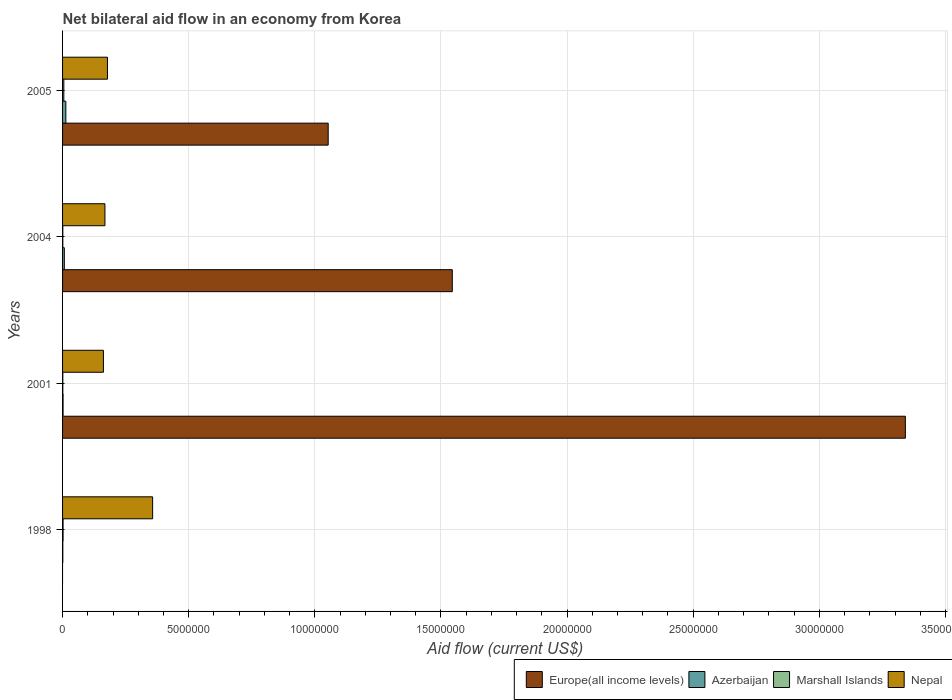How many different coloured bars are there?
Offer a very short reply. 4. Are the number of bars per tick equal to the number of legend labels?
Offer a very short reply. No. How many bars are there on the 4th tick from the top?
Provide a short and direct response. 3. How many bars are there on the 3rd tick from the bottom?
Ensure brevity in your answer.  4. Across all years, what is the minimum net bilateral aid flow in Europe(all income levels)?
Your answer should be compact. 0. In which year was the net bilateral aid flow in Marshall Islands maximum?
Your answer should be very brief. 2005. What is the total net bilateral aid flow in Marshall Islands in the graph?
Make the answer very short. 9.00e+04. What is the difference between the net bilateral aid flow in Nepal in 2004 and that in 2005?
Your response must be concise. -1.00e+05. What is the difference between the net bilateral aid flow in Europe(all income levels) in 1998 and the net bilateral aid flow in Marshall Islands in 2001?
Ensure brevity in your answer.  -10000. What is the average net bilateral aid flow in Nepal per year?
Keep it short and to the point. 2.16e+06. In the year 2001, what is the difference between the net bilateral aid flow in Nepal and net bilateral aid flow in Azerbaijan?
Offer a terse response. 1.60e+06. What is the ratio of the net bilateral aid flow in Marshall Islands in 2004 to that in 2005?
Your answer should be very brief. 0.2. Is the difference between the net bilateral aid flow in Nepal in 1998 and 2004 greater than the difference between the net bilateral aid flow in Azerbaijan in 1998 and 2004?
Provide a short and direct response. Yes. What is the difference between the highest and the second highest net bilateral aid flow in Marshall Islands?
Your answer should be compact. 3.00e+04. In how many years, is the net bilateral aid flow in Azerbaijan greater than the average net bilateral aid flow in Azerbaijan taken over all years?
Your response must be concise. 2. Is the sum of the net bilateral aid flow in Marshall Islands in 1998 and 2005 greater than the maximum net bilateral aid flow in Azerbaijan across all years?
Offer a very short reply. No. Is it the case that in every year, the sum of the net bilateral aid flow in Marshall Islands and net bilateral aid flow in Nepal is greater than the sum of net bilateral aid flow in Europe(all income levels) and net bilateral aid flow in Azerbaijan?
Give a very brief answer. Yes. Does the graph contain any zero values?
Your answer should be very brief. Yes. Does the graph contain grids?
Your answer should be compact. Yes. Where does the legend appear in the graph?
Offer a very short reply. Bottom right. How many legend labels are there?
Give a very brief answer. 4. How are the legend labels stacked?
Provide a succinct answer. Horizontal. What is the title of the graph?
Your answer should be compact. Net bilateral aid flow in an economy from Korea. What is the label or title of the X-axis?
Make the answer very short. Aid flow (current US$). What is the Aid flow (current US$) of Azerbaijan in 1998?
Offer a terse response. 10000. What is the Aid flow (current US$) in Nepal in 1998?
Keep it short and to the point. 3.57e+06. What is the Aid flow (current US$) in Europe(all income levels) in 2001?
Make the answer very short. 3.34e+07. What is the Aid flow (current US$) of Azerbaijan in 2001?
Your answer should be compact. 2.00e+04. What is the Aid flow (current US$) in Nepal in 2001?
Offer a very short reply. 1.62e+06. What is the Aid flow (current US$) of Europe(all income levels) in 2004?
Keep it short and to the point. 1.54e+07. What is the Aid flow (current US$) in Azerbaijan in 2004?
Provide a succinct answer. 7.00e+04. What is the Aid flow (current US$) of Nepal in 2004?
Offer a terse response. 1.68e+06. What is the Aid flow (current US$) of Europe(all income levels) in 2005?
Your response must be concise. 1.05e+07. What is the Aid flow (current US$) in Nepal in 2005?
Keep it short and to the point. 1.78e+06. Across all years, what is the maximum Aid flow (current US$) of Europe(all income levels)?
Your response must be concise. 3.34e+07. Across all years, what is the maximum Aid flow (current US$) in Azerbaijan?
Provide a short and direct response. 1.30e+05. Across all years, what is the maximum Aid flow (current US$) of Marshall Islands?
Offer a terse response. 5.00e+04. Across all years, what is the maximum Aid flow (current US$) of Nepal?
Offer a very short reply. 3.57e+06. Across all years, what is the minimum Aid flow (current US$) in Europe(all income levels)?
Your response must be concise. 0. Across all years, what is the minimum Aid flow (current US$) of Nepal?
Make the answer very short. 1.62e+06. What is the total Aid flow (current US$) in Europe(all income levels) in the graph?
Provide a short and direct response. 5.94e+07. What is the total Aid flow (current US$) in Azerbaijan in the graph?
Offer a very short reply. 2.30e+05. What is the total Aid flow (current US$) of Nepal in the graph?
Provide a short and direct response. 8.65e+06. What is the difference between the Aid flow (current US$) in Azerbaijan in 1998 and that in 2001?
Your answer should be compact. -10000. What is the difference between the Aid flow (current US$) in Nepal in 1998 and that in 2001?
Provide a succinct answer. 1.95e+06. What is the difference between the Aid flow (current US$) of Azerbaijan in 1998 and that in 2004?
Ensure brevity in your answer.  -6.00e+04. What is the difference between the Aid flow (current US$) of Marshall Islands in 1998 and that in 2004?
Your response must be concise. 10000. What is the difference between the Aid flow (current US$) of Nepal in 1998 and that in 2004?
Give a very brief answer. 1.89e+06. What is the difference between the Aid flow (current US$) in Nepal in 1998 and that in 2005?
Your response must be concise. 1.79e+06. What is the difference between the Aid flow (current US$) of Europe(all income levels) in 2001 and that in 2004?
Provide a succinct answer. 1.80e+07. What is the difference between the Aid flow (current US$) of Nepal in 2001 and that in 2004?
Offer a very short reply. -6.00e+04. What is the difference between the Aid flow (current US$) of Europe(all income levels) in 2001 and that in 2005?
Your answer should be very brief. 2.29e+07. What is the difference between the Aid flow (current US$) in Azerbaijan in 2001 and that in 2005?
Ensure brevity in your answer.  -1.10e+05. What is the difference between the Aid flow (current US$) in Nepal in 2001 and that in 2005?
Your answer should be compact. -1.60e+05. What is the difference between the Aid flow (current US$) of Europe(all income levels) in 2004 and that in 2005?
Your response must be concise. 4.92e+06. What is the difference between the Aid flow (current US$) in Azerbaijan in 2004 and that in 2005?
Provide a succinct answer. -6.00e+04. What is the difference between the Aid flow (current US$) of Nepal in 2004 and that in 2005?
Provide a succinct answer. -1.00e+05. What is the difference between the Aid flow (current US$) of Azerbaijan in 1998 and the Aid flow (current US$) of Marshall Islands in 2001?
Give a very brief answer. 0. What is the difference between the Aid flow (current US$) of Azerbaijan in 1998 and the Aid flow (current US$) of Nepal in 2001?
Your answer should be compact. -1.61e+06. What is the difference between the Aid flow (current US$) of Marshall Islands in 1998 and the Aid flow (current US$) of Nepal in 2001?
Your response must be concise. -1.60e+06. What is the difference between the Aid flow (current US$) of Azerbaijan in 1998 and the Aid flow (current US$) of Marshall Islands in 2004?
Ensure brevity in your answer.  0. What is the difference between the Aid flow (current US$) of Azerbaijan in 1998 and the Aid flow (current US$) of Nepal in 2004?
Your answer should be compact. -1.67e+06. What is the difference between the Aid flow (current US$) of Marshall Islands in 1998 and the Aid flow (current US$) of Nepal in 2004?
Your response must be concise. -1.66e+06. What is the difference between the Aid flow (current US$) of Azerbaijan in 1998 and the Aid flow (current US$) of Nepal in 2005?
Give a very brief answer. -1.77e+06. What is the difference between the Aid flow (current US$) of Marshall Islands in 1998 and the Aid flow (current US$) of Nepal in 2005?
Your response must be concise. -1.76e+06. What is the difference between the Aid flow (current US$) of Europe(all income levels) in 2001 and the Aid flow (current US$) of Azerbaijan in 2004?
Ensure brevity in your answer.  3.33e+07. What is the difference between the Aid flow (current US$) in Europe(all income levels) in 2001 and the Aid flow (current US$) in Marshall Islands in 2004?
Ensure brevity in your answer.  3.34e+07. What is the difference between the Aid flow (current US$) of Europe(all income levels) in 2001 and the Aid flow (current US$) of Nepal in 2004?
Give a very brief answer. 3.17e+07. What is the difference between the Aid flow (current US$) of Azerbaijan in 2001 and the Aid flow (current US$) of Nepal in 2004?
Your answer should be compact. -1.66e+06. What is the difference between the Aid flow (current US$) of Marshall Islands in 2001 and the Aid flow (current US$) of Nepal in 2004?
Your answer should be very brief. -1.67e+06. What is the difference between the Aid flow (current US$) in Europe(all income levels) in 2001 and the Aid flow (current US$) in Azerbaijan in 2005?
Offer a very short reply. 3.33e+07. What is the difference between the Aid flow (current US$) of Europe(all income levels) in 2001 and the Aid flow (current US$) of Marshall Islands in 2005?
Your answer should be compact. 3.34e+07. What is the difference between the Aid flow (current US$) of Europe(all income levels) in 2001 and the Aid flow (current US$) of Nepal in 2005?
Offer a very short reply. 3.16e+07. What is the difference between the Aid flow (current US$) of Azerbaijan in 2001 and the Aid flow (current US$) of Nepal in 2005?
Your response must be concise. -1.76e+06. What is the difference between the Aid flow (current US$) in Marshall Islands in 2001 and the Aid flow (current US$) in Nepal in 2005?
Ensure brevity in your answer.  -1.77e+06. What is the difference between the Aid flow (current US$) of Europe(all income levels) in 2004 and the Aid flow (current US$) of Azerbaijan in 2005?
Keep it short and to the point. 1.53e+07. What is the difference between the Aid flow (current US$) of Europe(all income levels) in 2004 and the Aid flow (current US$) of Marshall Islands in 2005?
Your response must be concise. 1.54e+07. What is the difference between the Aid flow (current US$) in Europe(all income levels) in 2004 and the Aid flow (current US$) in Nepal in 2005?
Offer a very short reply. 1.37e+07. What is the difference between the Aid flow (current US$) in Azerbaijan in 2004 and the Aid flow (current US$) in Nepal in 2005?
Ensure brevity in your answer.  -1.71e+06. What is the difference between the Aid flow (current US$) in Marshall Islands in 2004 and the Aid flow (current US$) in Nepal in 2005?
Ensure brevity in your answer.  -1.77e+06. What is the average Aid flow (current US$) of Europe(all income levels) per year?
Offer a very short reply. 1.48e+07. What is the average Aid flow (current US$) in Azerbaijan per year?
Give a very brief answer. 5.75e+04. What is the average Aid flow (current US$) in Marshall Islands per year?
Offer a terse response. 2.25e+04. What is the average Aid flow (current US$) of Nepal per year?
Give a very brief answer. 2.16e+06. In the year 1998, what is the difference between the Aid flow (current US$) in Azerbaijan and Aid flow (current US$) in Marshall Islands?
Your answer should be compact. -10000. In the year 1998, what is the difference between the Aid flow (current US$) of Azerbaijan and Aid flow (current US$) of Nepal?
Keep it short and to the point. -3.56e+06. In the year 1998, what is the difference between the Aid flow (current US$) in Marshall Islands and Aid flow (current US$) in Nepal?
Give a very brief answer. -3.55e+06. In the year 2001, what is the difference between the Aid flow (current US$) in Europe(all income levels) and Aid flow (current US$) in Azerbaijan?
Provide a short and direct response. 3.34e+07. In the year 2001, what is the difference between the Aid flow (current US$) of Europe(all income levels) and Aid flow (current US$) of Marshall Islands?
Keep it short and to the point. 3.34e+07. In the year 2001, what is the difference between the Aid flow (current US$) in Europe(all income levels) and Aid flow (current US$) in Nepal?
Offer a terse response. 3.18e+07. In the year 2001, what is the difference between the Aid flow (current US$) of Azerbaijan and Aid flow (current US$) of Nepal?
Provide a short and direct response. -1.60e+06. In the year 2001, what is the difference between the Aid flow (current US$) in Marshall Islands and Aid flow (current US$) in Nepal?
Your response must be concise. -1.61e+06. In the year 2004, what is the difference between the Aid flow (current US$) of Europe(all income levels) and Aid flow (current US$) of Azerbaijan?
Offer a very short reply. 1.54e+07. In the year 2004, what is the difference between the Aid flow (current US$) in Europe(all income levels) and Aid flow (current US$) in Marshall Islands?
Your response must be concise. 1.54e+07. In the year 2004, what is the difference between the Aid flow (current US$) of Europe(all income levels) and Aid flow (current US$) of Nepal?
Ensure brevity in your answer.  1.38e+07. In the year 2004, what is the difference between the Aid flow (current US$) in Azerbaijan and Aid flow (current US$) in Marshall Islands?
Offer a terse response. 6.00e+04. In the year 2004, what is the difference between the Aid flow (current US$) in Azerbaijan and Aid flow (current US$) in Nepal?
Provide a succinct answer. -1.61e+06. In the year 2004, what is the difference between the Aid flow (current US$) of Marshall Islands and Aid flow (current US$) of Nepal?
Give a very brief answer. -1.67e+06. In the year 2005, what is the difference between the Aid flow (current US$) of Europe(all income levels) and Aid flow (current US$) of Azerbaijan?
Ensure brevity in your answer.  1.04e+07. In the year 2005, what is the difference between the Aid flow (current US$) in Europe(all income levels) and Aid flow (current US$) in Marshall Islands?
Your response must be concise. 1.05e+07. In the year 2005, what is the difference between the Aid flow (current US$) of Europe(all income levels) and Aid flow (current US$) of Nepal?
Your answer should be very brief. 8.75e+06. In the year 2005, what is the difference between the Aid flow (current US$) in Azerbaijan and Aid flow (current US$) in Marshall Islands?
Provide a short and direct response. 8.00e+04. In the year 2005, what is the difference between the Aid flow (current US$) in Azerbaijan and Aid flow (current US$) in Nepal?
Provide a short and direct response. -1.65e+06. In the year 2005, what is the difference between the Aid flow (current US$) in Marshall Islands and Aid flow (current US$) in Nepal?
Keep it short and to the point. -1.73e+06. What is the ratio of the Aid flow (current US$) in Azerbaijan in 1998 to that in 2001?
Offer a very short reply. 0.5. What is the ratio of the Aid flow (current US$) in Nepal in 1998 to that in 2001?
Make the answer very short. 2.2. What is the ratio of the Aid flow (current US$) in Azerbaijan in 1998 to that in 2004?
Provide a short and direct response. 0.14. What is the ratio of the Aid flow (current US$) in Nepal in 1998 to that in 2004?
Your answer should be compact. 2.12. What is the ratio of the Aid flow (current US$) in Azerbaijan in 1998 to that in 2005?
Your answer should be very brief. 0.08. What is the ratio of the Aid flow (current US$) of Marshall Islands in 1998 to that in 2005?
Keep it short and to the point. 0.4. What is the ratio of the Aid flow (current US$) in Nepal in 1998 to that in 2005?
Your answer should be compact. 2.01. What is the ratio of the Aid flow (current US$) in Europe(all income levels) in 2001 to that in 2004?
Give a very brief answer. 2.16. What is the ratio of the Aid flow (current US$) of Azerbaijan in 2001 to that in 2004?
Keep it short and to the point. 0.29. What is the ratio of the Aid flow (current US$) of Europe(all income levels) in 2001 to that in 2005?
Your answer should be compact. 3.17. What is the ratio of the Aid flow (current US$) of Azerbaijan in 2001 to that in 2005?
Provide a succinct answer. 0.15. What is the ratio of the Aid flow (current US$) in Marshall Islands in 2001 to that in 2005?
Keep it short and to the point. 0.2. What is the ratio of the Aid flow (current US$) of Nepal in 2001 to that in 2005?
Provide a succinct answer. 0.91. What is the ratio of the Aid flow (current US$) of Europe(all income levels) in 2004 to that in 2005?
Your answer should be compact. 1.47. What is the ratio of the Aid flow (current US$) of Azerbaijan in 2004 to that in 2005?
Make the answer very short. 0.54. What is the ratio of the Aid flow (current US$) in Nepal in 2004 to that in 2005?
Provide a short and direct response. 0.94. What is the difference between the highest and the second highest Aid flow (current US$) of Europe(all income levels)?
Offer a terse response. 1.80e+07. What is the difference between the highest and the second highest Aid flow (current US$) in Marshall Islands?
Your answer should be compact. 3.00e+04. What is the difference between the highest and the second highest Aid flow (current US$) of Nepal?
Offer a terse response. 1.79e+06. What is the difference between the highest and the lowest Aid flow (current US$) in Europe(all income levels)?
Provide a short and direct response. 3.34e+07. What is the difference between the highest and the lowest Aid flow (current US$) of Azerbaijan?
Your answer should be compact. 1.20e+05. What is the difference between the highest and the lowest Aid flow (current US$) of Marshall Islands?
Give a very brief answer. 4.00e+04. What is the difference between the highest and the lowest Aid flow (current US$) in Nepal?
Your response must be concise. 1.95e+06. 